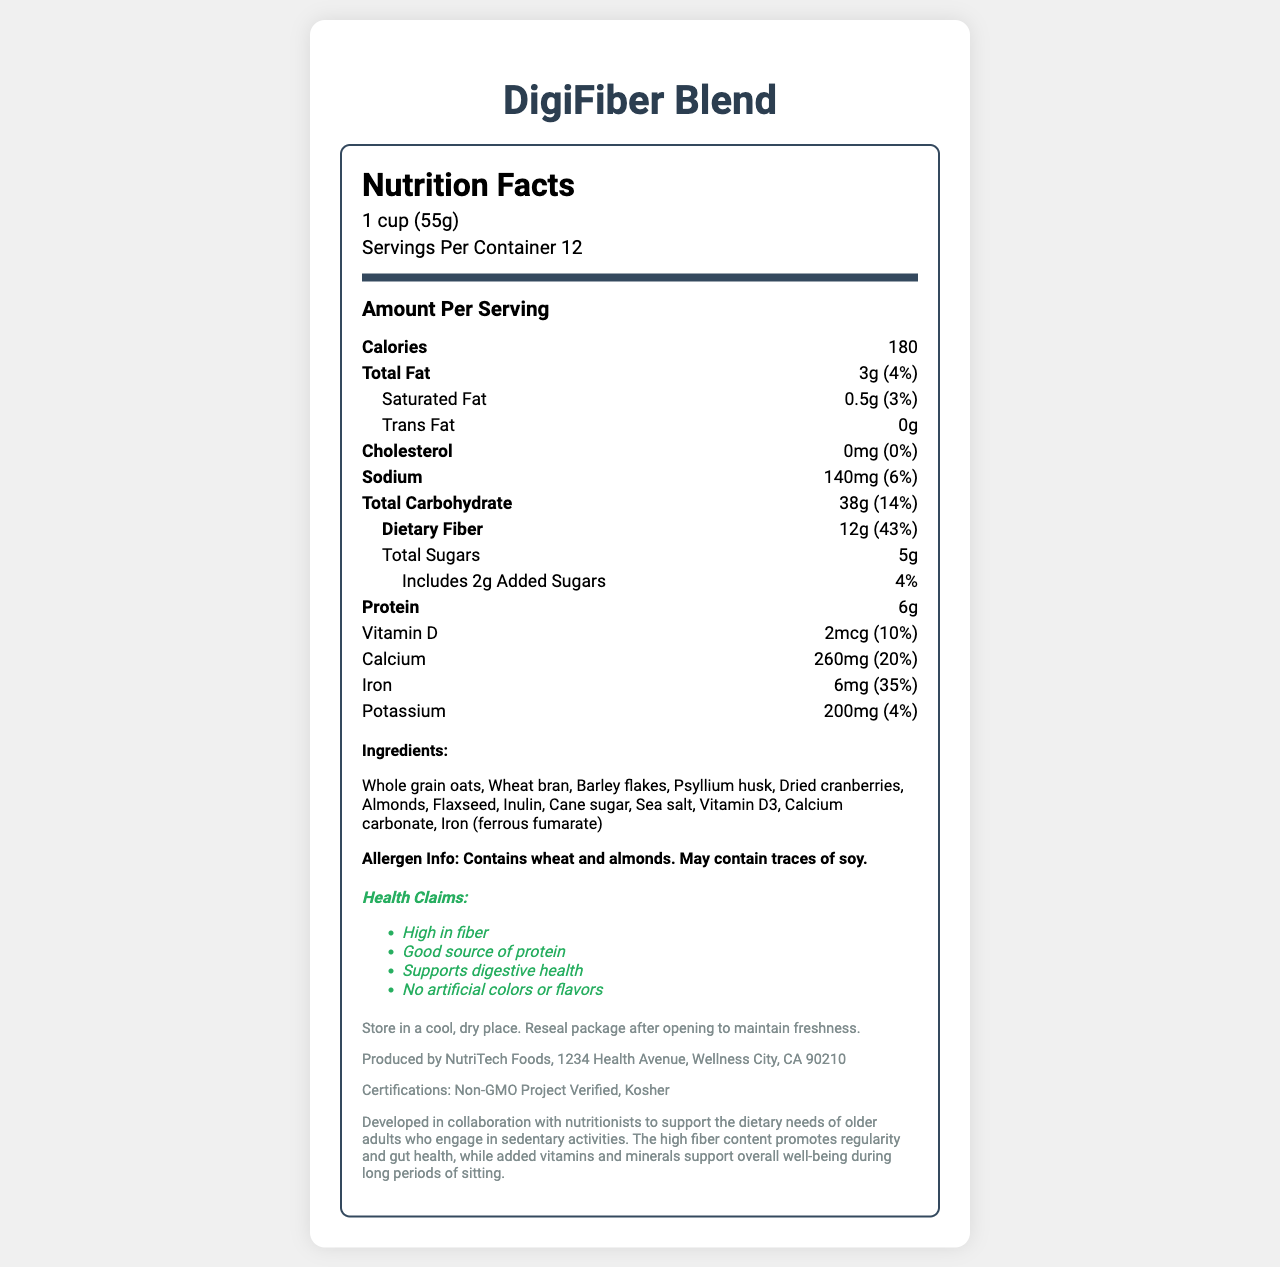what is the serving size? The serving size is listed at the beginning of the Nutrition Facts section.
Answer: 1 cup (55g) how many servings per container? The number of servings per container is stated in the Nutrition Facts section.
Answer: 12 how many calories are there per serving? The calories per serving are shown under the "Amount Per Serving" heading.
Answer: 180 what is the total fat content per serving? The total fat content per serving is listed in both grams and as a percentage of the daily value.
Answer: 3g (4%) how much dietary fiber is in each serving? The dietary fiber content is tracked both in grams and as a percentage of the daily value in the Nutrition Facts section.
Answer: 12g (43%) which ingredient is listed first? A. Psyllium husk, B. Whole grain oats, C. Iron (ferrous fumarate), D. Dried cranberries Ingredients are usually listed in descending order by weight, and Whole grain oats is the first listed ingredient.
Answer: B. Whole grain oats what percentage of the daily value of calcium does a serving provide? A. 10%, B. 20%, C. 30%, D. 40% The daily value of calcium per serving is noted as 20%.
Answer: B. 20% are there any saturated fats in the cereal? 0.5g of saturated fat per serving is indicated in the Nutrition Facts section.
Answer: Yes does this product contain soy? The allergen info section indicates that it may contain traces of soy.
Answer: May contain traces of soy does this cereal support digestive health? One of the health claims explicitly states that it supports digestive health.
Answer: True summarize the document. The summary encapsulates the main points of the Nutrition Facts label, describing nutritional content, ingredients, health claims, and manufacturer information.
Answer: DigiFiber Blend is a high-fiber cereal blend designed for older adults who spend long hours seated. The product has 180 calories per 1 cup serving, with key nutrients like 12g of dietary fiber, 6g of protein, and various vitamins and minerals. The cereal contains ingredients like whole grain oats, wheat bran, and dried cranberries, and it is free of artificial colors and flavors. It is produced by NutriTech Foods and is Non-GMO and Kosher certified. how many grams of sugar are added to the cereal? The amount of added sugars is explicitly listed as 2g in the Nutrition Facts.
Answer: 2g who is the manufacturer of this cereal? The manufacturer information section lists NutriTech Foods as the producer.
Answer: NutriTech Foods is the cereal Kosher certified? The certifications section includes Kosher certification.
Answer: Yes why was this cereal developed? The document does not provide specific reasons for developing the cereal aside from general benefits. The reason for development might be inferred but is not explicitly mentioned.
Answer: Cannot be determined 